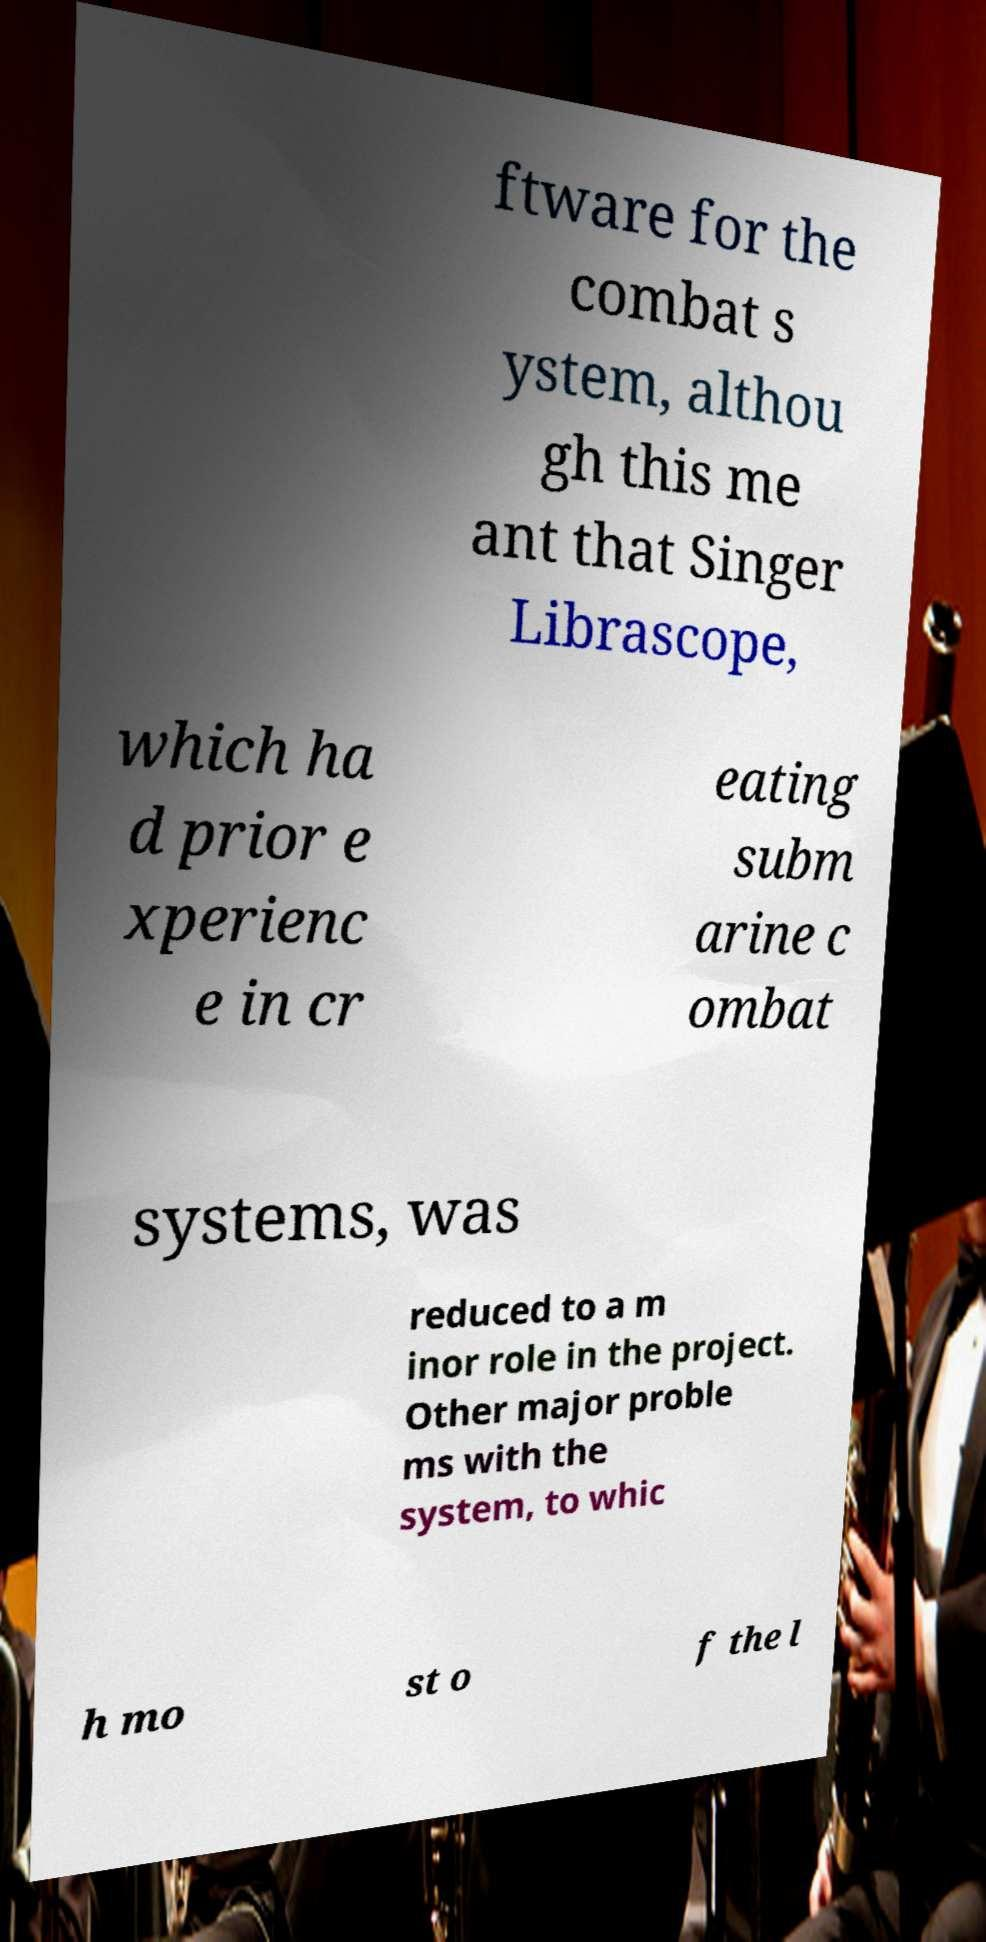Can you read and provide the text displayed in the image?This photo seems to have some interesting text. Can you extract and type it out for me? ftware for the combat s ystem, althou gh this me ant that Singer Librascope, which ha d prior e xperienc e in cr eating subm arine c ombat systems, was reduced to a m inor role in the project. Other major proble ms with the system, to whic h mo st o f the l 